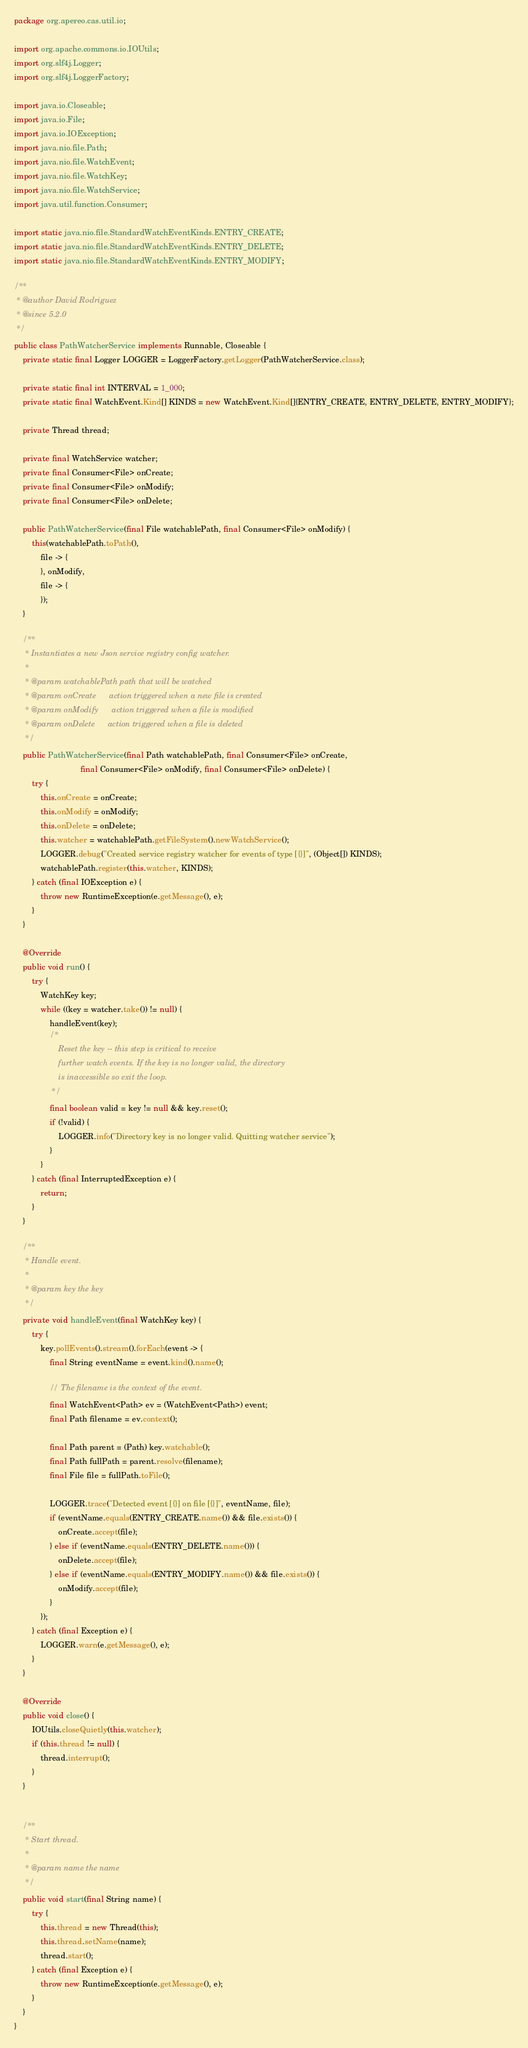<code> <loc_0><loc_0><loc_500><loc_500><_Java_>package org.apereo.cas.util.io;

import org.apache.commons.io.IOUtils;
import org.slf4j.Logger;
import org.slf4j.LoggerFactory;

import java.io.Closeable;
import java.io.File;
import java.io.IOException;
import java.nio.file.Path;
import java.nio.file.WatchEvent;
import java.nio.file.WatchKey;
import java.nio.file.WatchService;
import java.util.function.Consumer;

import static java.nio.file.StandardWatchEventKinds.ENTRY_CREATE;
import static java.nio.file.StandardWatchEventKinds.ENTRY_DELETE;
import static java.nio.file.StandardWatchEventKinds.ENTRY_MODIFY;

/**
 * @author David Rodriguez
 * @since 5.2.0
 */
public class PathWatcherService implements Runnable, Closeable {
    private static final Logger LOGGER = LoggerFactory.getLogger(PathWatcherService.class);

    private static final int INTERVAL = 1_000;
    private static final WatchEvent.Kind[] KINDS = new WatchEvent.Kind[]{ENTRY_CREATE, ENTRY_DELETE, ENTRY_MODIFY};

    private Thread thread;

    private final WatchService watcher;
    private final Consumer<File> onCreate;
    private final Consumer<File> onModify;
    private final Consumer<File> onDelete;

    public PathWatcherService(final File watchablePath, final Consumer<File> onModify) {
        this(watchablePath.toPath(),
            file -> {
            }, onModify,
            file -> {
            });
    }

    /**
     * Instantiates a new Json service registry config watcher.
     *
     * @param watchablePath path that will be watched
     * @param onCreate      action triggered when a new file is created
     * @param onModify      action triggered when a file is modified
     * @param onDelete      action triggered when a file is deleted
     */
    public PathWatcherService(final Path watchablePath, final Consumer<File> onCreate,
                              final Consumer<File> onModify, final Consumer<File> onDelete) {
        try {
            this.onCreate = onCreate;
            this.onModify = onModify;
            this.onDelete = onDelete;
            this.watcher = watchablePath.getFileSystem().newWatchService();
            LOGGER.debug("Created service registry watcher for events of type [{}]", (Object[]) KINDS);
            watchablePath.register(this.watcher, KINDS);
        } catch (final IOException e) {
            throw new RuntimeException(e.getMessage(), e);
        }
    }

    @Override
    public void run() {
        try {
            WatchKey key;
            while ((key = watcher.take()) != null) {
                handleEvent(key);
                /*
                    Reset the key -- this step is critical to receive
                    further watch events. If the key is no longer valid, the directory
                    is inaccessible so exit the loop.
                 */
                final boolean valid = key != null && key.reset();
                if (!valid) {
                    LOGGER.info("Directory key is no longer valid. Quitting watcher service");
                }
            }
        } catch (final InterruptedException e) {
            return;
        }
    }

    /**
     * Handle event.
     *
     * @param key the key
     */
    private void handleEvent(final WatchKey key) {
        try {
            key.pollEvents().stream().forEach(event -> {
                final String eventName = event.kind().name();

                // The filename is the context of the event.
                final WatchEvent<Path> ev = (WatchEvent<Path>) event;
                final Path filename = ev.context();

                final Path parent = (Path) key.watchable();
                final Path fullPath = parent.resolve(filename);
                final File file = fullPath.toFile();

                LOGGER.trace("Detected event [{}] on file [{}]", eventName, file);
                if (eventName.equals(ENTRY_CREATE.name()) && file.exists()) {
                    onCreate.accept(file);
                } else if (eventName.equals(ENTRY_DELETE.name())) {
                    onDelete.accept(file);
                } else if (eventName.equals(ENTRY_MODIFY.name()) && file.exists()) {
                    onModify.accept(file);
                }
            });
        } catch (final Exception e) {
            LOGGER.warn(e.getMessage(), e);
        }
    }

    @Override
    public void close() {
        IOUtils.closeQuietly(this.watcher);
        if (this.thread != null) {
            thread.interrupt();
        }
    }


    /**
     * Start thread.
     *
     * @param name the name
     */
    public void start(final String name) {
        try {
            this.thread = new Thread(this);
            this.thread.setName(name);
            thread.start();
        } catch (final Exception e) {
            throw new RuntimeException(e.getMessage(), e);
        }
    }
}
</code> 